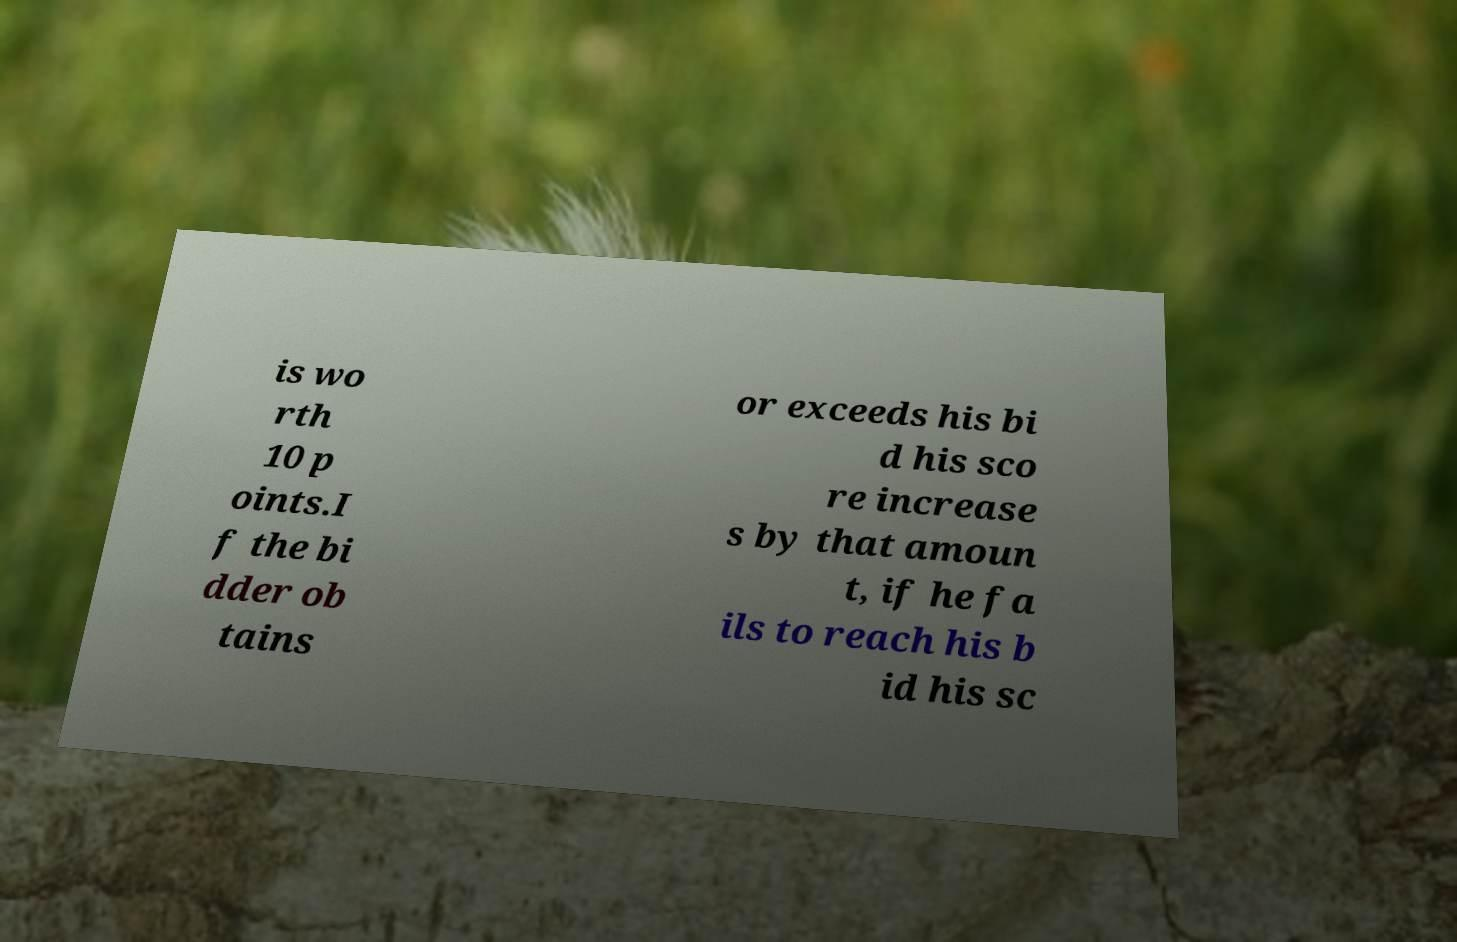Please identify and transcribe the text found in this image. is wo rth 10 p oints.I f the bi dder ob tains or exceeds his bi d his sco re increase s by that amoun t, if he fa ils to reach his b id his sc 